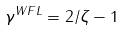<formula> <loc_0><loc_0><loc_500><loc_500>\gamma ^ { W F L } = 2 / \zeta - 1</formula> 